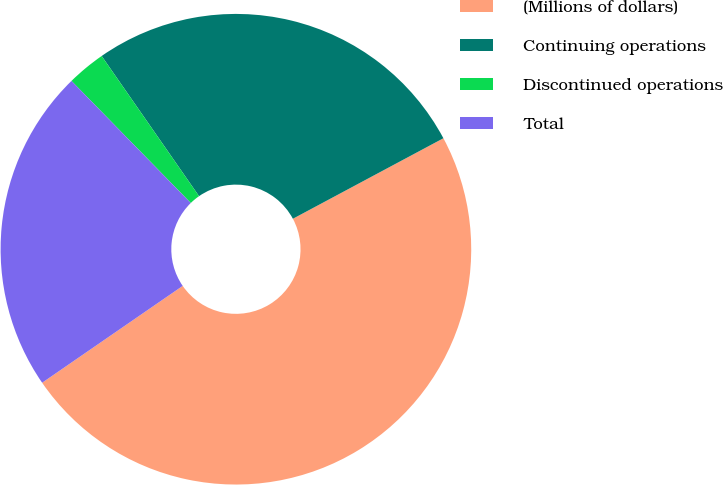Convert chart. <chart><loc_0><loc_0><loc_500><loc_500><pie_chart><fcel>(Millions of dollars)<fcel>Continuing operations<fcel>Discontinued operations<fcel>Total<nl><fcel>48.22%<fcel>26.85%<fcel>2.65%<fcel>22.29%<nl></chart> 